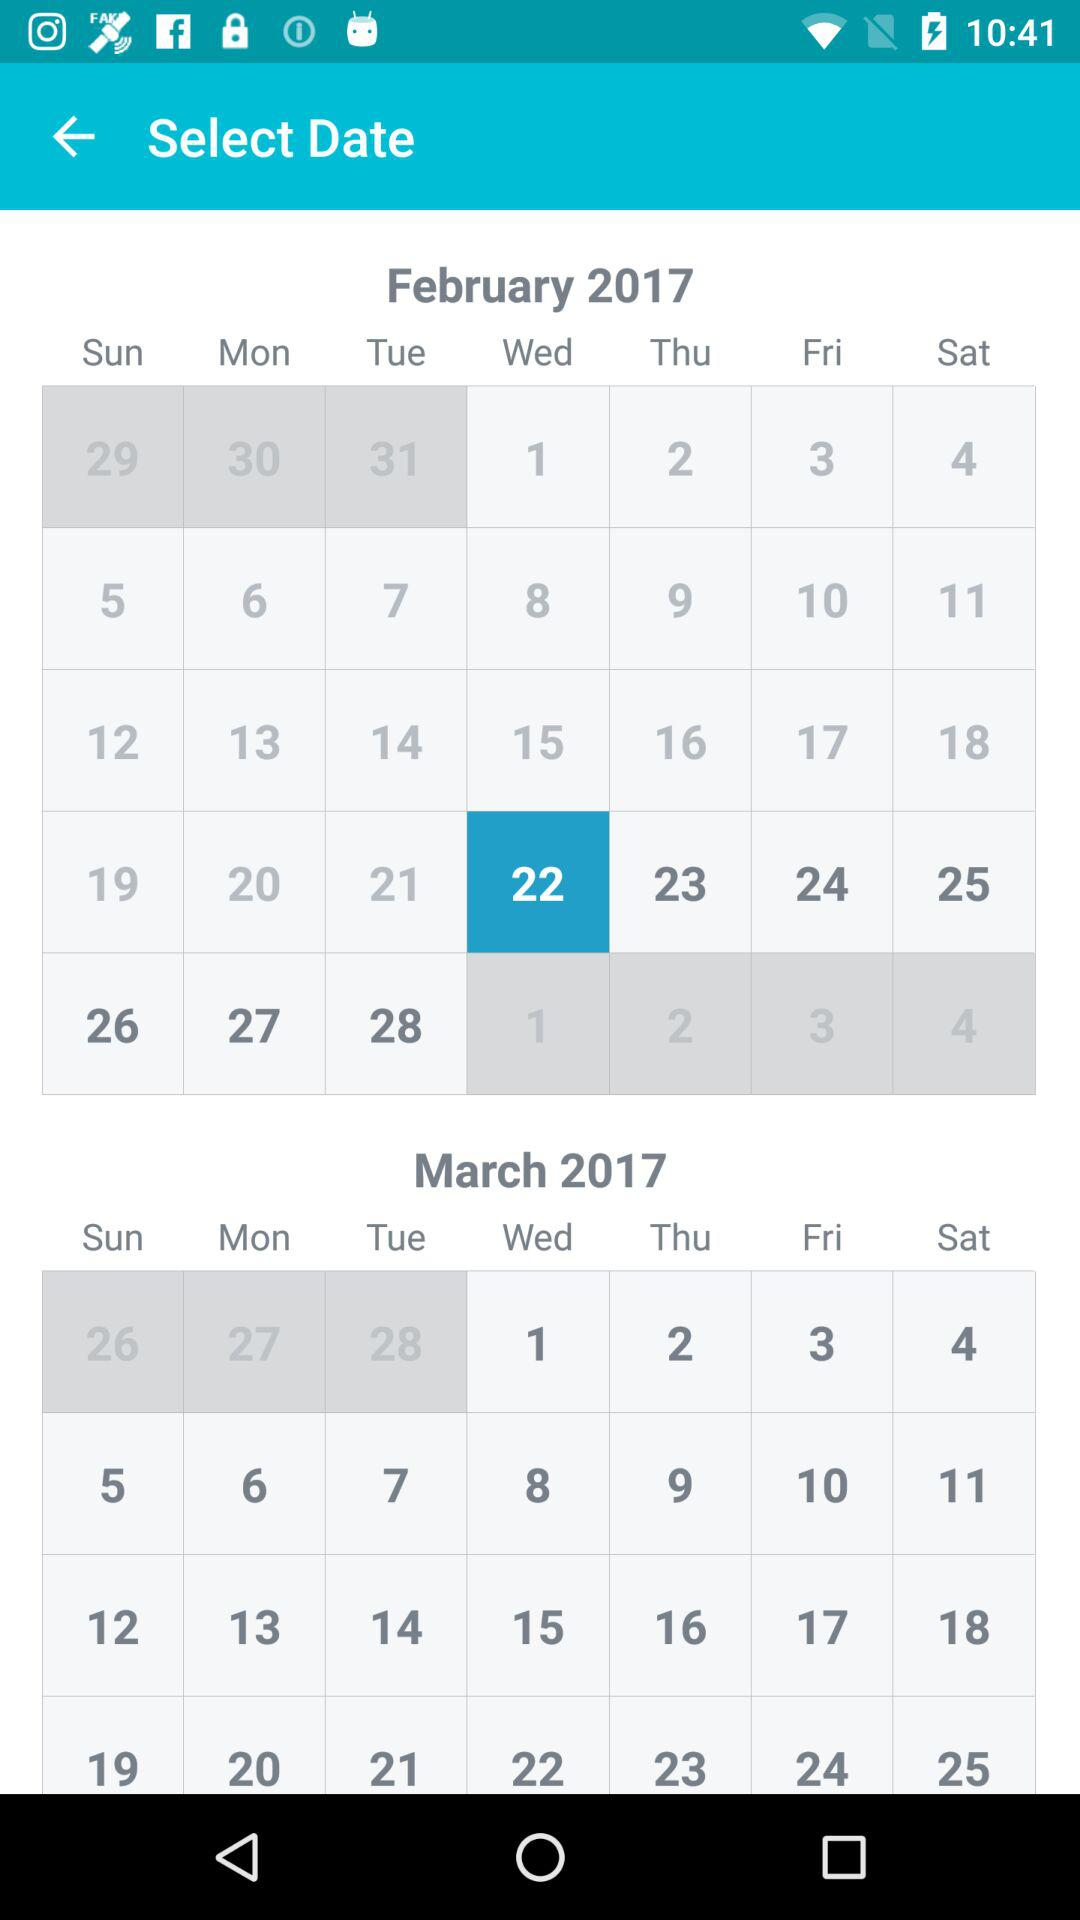Which date in February of the year 2017 has been selected? The selected date is 22. 